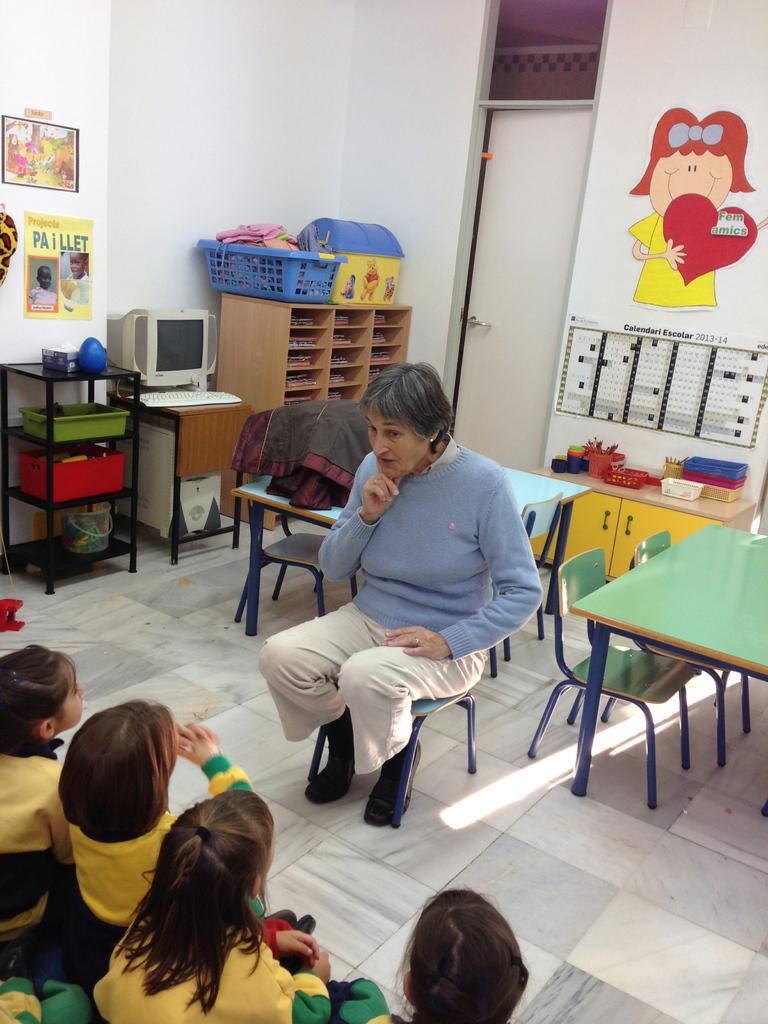What year is the calendar on the back?
Give a very brief answer. 2013-14. What does the yellow sign to the left say?
Make the answer very short. Paillet. 